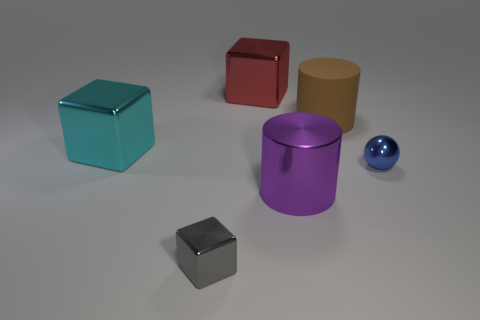Subtract all large metal cubes. How many cubes are left? 1 Subtract all red blocks. How many blocks are left? 2 Subtract all big cyan shiny cubes. Subtract all gray things. How many objects are left? 4 Add 3 big cyan blocks. How many big cyan blocks are left? 4 Add 3 small cubes. How many small cubes exist? 4 Add 4 big purple cylinders. How many objects exist? 10 Subtract 1 blue balls. How many objects are left? 5 Subtract all cylinders. How many objects are left? 4 Subtract 3 blocks. How many blocks are left? 0 Subtract all brown cylinders. Subtract all red balls. How many cylinders are left? 1 